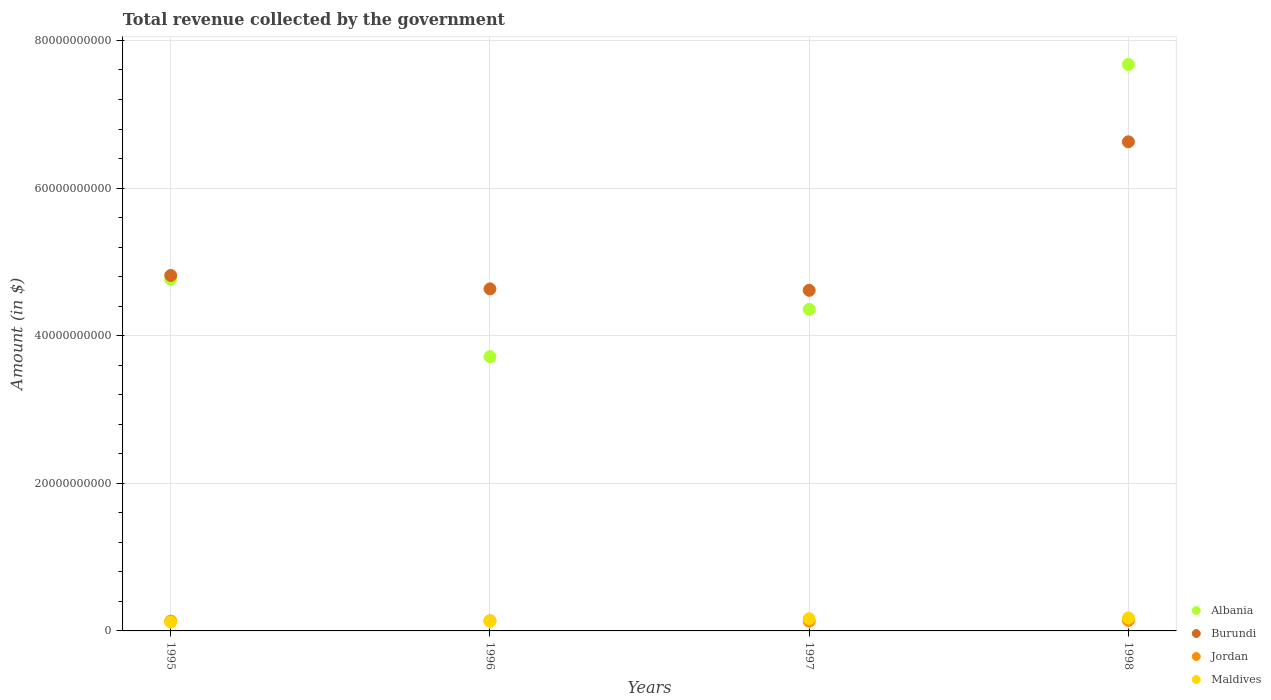What is the total revenue collected by the government in Albania in 1995?
Keep it short and to the point. 4.76e+1. Across all years, what is the maximum total revenue collected by the government in Albania?
Your response must be concise. 7.67e+1. Across all years, what is the minimum total revenue collected by the government in Jordan?
Your answer should be very brief. 1.31e+09. In which year was the total revenue collected by the government in Maldives maximum?
Keep it short and to the point. 1998. In which year was the total revenue collected by the government in Burundi minimum?
Your response must be concise. 1997. What is the total total revenue collected by the government in Maldives in the graph?
Give a very brief answer. 5.94e+09. What is the difference between the total revenue collected by the government in Maldives in 1995 and that in 1998?
Your answer should be very brief. -5.58e+08. What is the difference between the total revenue collected by the government in Maldives in 1997 and the total revenue collected by the government in Albania in 1995?
Ensure brevity in your answer.  -4.60e+1. What is the average total revenue collected by the government in Burundi per year?
Provide a succinct answer. 5.17e+1. In the year 1997, what is the difference between the total revenue collected by the government in Burundi and total revenue collected by the government in Jordan?
Your answer should be compact. 4.48e+1. In how many years, is the total revenue collected by the government in Jordan greater than 24000000000 $?
Provide a succinct answer. 0. What is the ratio of the total revenue collected by the government in Jordan in 1995 to that in 1998?
Keep it short and to the point. 0.94. Is the difference between the total revenue collected by the government in Burundi in 1995 and 1997 greater than the difference between the total revenue collected by the government in Jordan in 1995 and 1997?
Make the answer very short. Yes. What is the difference between the highest and the second highest total revenue collected by the government in Maldives?
Your response must be concise. 1.12e+08. What is the difference between the highest and the lowest total revenue collected by the government in Albania?
Offer a very short reply. 3.96e+1. In how many years, is the total revenue collected by the government in Jordan greater than the average total revenue collected by the government in Jordan taken over all years?
Ensure brevity in your answer.  2. Is it the case that in every year, the sum of the total revenue collected by the government in Burundi and total revenue collected by the government in Jordan  is greater than the sum of total revenue collected by the government in Albania and total revenue collected by the government in Maldives?
Provide a short and direct response. Yes. Is it the case that in every year, the sum of the total revenue collected by the government in Jordan and total revenue collected by the government in Maldives  is greater than the total revenue collected by the government in Burundi?
Your answer should be compact. No. Does the total revenue collected by the government in Maldives monotonically increase over the years?
Keep it short and to the point. Yes. Is the total revenue collected by the government in Jordan strictly less than the total revenue collected by the government in Burundi over the years?
Give a very brief answer. Yes. How many years are there in the graph?
Ensure brevity in your answer.  4. What is the difference between two consecutive major ticks on the Y-axis?
Provide a short and direct response. 2.00e+1. Are the values on the major ticks of Y-axis written in scientific E-notation?
Make the answer very short. No. Does the graph contain any zero values?
Your response must be concise. No. Does the graph contain grids?
Give a very brief answer. Yes. Where does the legend appear in the graph?
Offer a very short reply. Bottom right. How many legend labels are there?
Ensure brevity in your answer.  4. What is the title of the graph?
Your response must be concise. Total revenue collected by the government. What is the label or title of the X-axis?
Provide a short and direct response. Years. What is the label or title of the Y-axis?
Your answer should be very brief. Amount (in $). What is the Amount (in $) in Albania in 1995?
Give a very brief answer. 4.76e+1. What is the Amount (in $) of Burundi in 1995?
Offer a very short reply. 4.82e+1. What is the Amount (in $) of Jordan in 1995?
Make the answer very short. 1.33e+09. What is the Amount (in $) in Maldives in 1995?
Your answer should be compact. 1.21e+09. What is the Amount (in $) in Albania in 1996?
Your response must be concise. 3.72e+1. What is the Amount (in $) in Burundi in 1996?
Your answer should be compact. 4.63e+1. What is the Amount (in $) in Jordan in 1996?
Give a very brief answer. 1.36e+09. What is the Amount (in $) in Maldives in 1996?
Your answer should be very brief. 1.32e+09. What is the Amount (in $) in Albania in 1997?
Ensure brevity in your answer.  4.36e+1. What is the Amount (in $) of Burundi in 1997?
Your response must be concise. 4.61e+1. What is the Amount (in $) in Jordan in 1997?
Your answer should be compact. 1.31e+09. What is the Amount (in $) in Maldives in 1997?
Ensure brevity in your answer.  1.65e+09. What is the Amount (in $) in Albania in 1998?
Make the answer very short. 7.67e+1. What is the Amount (in $) of Burundi in 1998?
Give a very brief answer. 6.63e+1. What is the Amount (in $) in Jordan in 1998?
Keep it short and to the point. 1.42e+09. What is the Amount (in $) of Maldives in 1998?
Your answer should be very brief. 1.76e+09. Across all years, what is the maximum Amount (in $) in Albania?
Offer a very short reply. 7.67e+1. Across all years, what is the maximum Amount (in $) in Burundi?
Keep it short and to the point. 6.63e+1. Across all years, what is the maximum Amount (in $) in Jordan?
Your answer should be very brief. 1.42e+09. Across all years, what is the maximum Amount (in $) in Maldives?
Offer a very short reply. 1.76e+09. Across all years, what is the minimum Amount (in $) in Albania?
Keep it short and to the point. 3.72e+1. Across all years, what is the minimum Amount (in $) of Burundi?
Keep it short and to the point. 4.61e+1. Across all years, what is the minimum Amount (in $) in Jordan?
Give a very brief answer. 1.31e+09. Across all years, what is the minimum Amount (in $) of Maldives?
Your response must be concise. 1.21e+09. What is the total Amount (in $) of Albania in the graph?
Your response must be concise. 2.05e+11. What is the total Amount (in $) in Burundi in the graph?
Ensure brevity in your answer.  2.07e+11. What is the total Amount (in $) in Jordan in the graph?
Your answer should be compact. 5.43e+09. What is the total Amount (in $) of Maldives in the graph?
Offer a terse response. 5.94e+09. What is the difference between the Amount (in $) in Albania in 1995 and that in 1996?
Keep it short and to the point. 1.05e+1. What is the difference between the Amount (in $) in Burundi in 1995 and that in 1996?
Make the answer very short. 1.81e+09. What is the difference between the Amount (in $) in Jordan in 1995 and that in 1996?
Offer a very short reply. -3.30e+07. What is the difference between the Amount (in $) in Maldives in 1995 and that in 1996?
Provide a succinct answer. -1.16e+08. What is the difference between the Amount (in $) of Albania in 1995 and that in 1997?
Provide a succinct answer. 4.08e+09. What is the difference between the Amount (in $) in Burundi in 1995 and that in 1997?
Offer a very short reply. 2.01e+09. What is the difference between the Amount (in $) of Jordan in 1995 and that in 1997?
Your answer should be compact. 1.93e+07. What is the difference between the Amount (in $) of Maldives in 1995 and that in 1997?
Offer a very short reply. -4.46e+08. What is the difference between the Amount (in $) of Albania in 1995 and that in 1998?
Keep it short and to the point. -2.91e+1. What is the difference between the Amount (in $) in Burundi in 1995 and that in 1998?
Give a very brief answer. -1.81e+1. What is the difference between the Amount (in $) in Jordan in 1995 and that in 1998?
Give a very brief answer. -9.02e+07. What is the difference between the Amount (in $) in Maldives in 1995 and that in 1998?
Make the answer very short. -5.58e+08. What is the difference between the Amount (in $) in Albania in 1996 and that in 1997?
Provide a short and direct response. -6.41e+09. What is the difference between the Amount (in $) in Jordan in 1996 and that in 1997?
Provide a succinct answer. 5.23e+07. What is the difference between the Amount (in $) in Maldives in 1996 and that in 1997?
Offer a very short reply. -3.30e+08. What is the difference between the Amount (in $) of Albania in 1996 and that in 1998?
Make the answer very short. -3.96e+1. What is the difference between the Amount (in $) of Burundi in 1996 and that in 1998?
Your response must be concise. -1.99e+1. What is the difference between the Amount (in $) in Jordan in 1996 and that in 1998?
Offer a very short reply. -5.73e+07. What is the difference between the Amount (in $) of Maldives in 1996 and that in 1998?
Keep it short and to the point. -4.42e+08. What is the difference between the Amount (in $) of Albania in 1997 and that in 1998?
Offer a terse response. -3.32e+1. What is the difference between the Amount (in $) in Burundi in 1997 and that in 1998?
Your answer should be very brief. -2.01e+1. What is the difference between the Amount (in $) of Jordan in 1997 and that in 1998?
Give a very brief answer. -1.10e+08. What is the difference between the Amount (in $) of Maldives in 1997 and that in 1998?
Make the answer very short. -1.12e+08. What is the difference between the Amount (in $) of Albania in 1995 and the Amount (in $) of Burundi in 1996?
Your response must be concise. 1.30e+09. What is the difference between the Amount (in $) of Albania in 1995 and the Amount (in $) of Jordan in 1996?
Provide a succinct answer. 4.63e+1. What is the difference between the Amount (in $) of Albania in 1995 and the Amount (in $) of Maldives in 1996?
Your answer should be very brief. 4.63e+1. What is the difference between the Amount (in $) in Burundi in 1995 and the Amount (in $) in Jordan in 1996?
Ensure brevity in your answer.  4.68e+1. What is the difference between the Amount (in $) of Burundi in 1995 and the Amount (in $) of Maldives in 1996?
Provide a succinct answer. 4.68e+1. What is the difference between the Amount (in $) of Jordan in 1995 and the Amount (in $) of Maldives in 1996?
Your answer should be compact. 9.48e+06. What is the difference between the Amount (in $) of Albania in 1995 and the Amount (in $) of Burundi in 1997?
Your answer should be compact. 1.50e+09. What is the difference between the Amount (in $) in Albania in 1995 and the Amount (in $) in Jordan in 1997?
Offer a very short reply. 4.63e+1. What is the difference between the Amount (in $) of Albania in 1995 and the Amount (in $) of Maldives in 1997?
Make the answer very short. 4.60e+1. What is the difference between the Amount (in $) in Burundi in 1995 and the Amount (in $) in Jordan in 1997?
Your response must be concise. 4.68e+1. What is the difference between the Amount (in $) of Burundi in 1995 and the Amount (in $) of Maldives in 1997?
Make the answer very short. 4.65e+1. What is the difference between the Amount (in $) in Jordan in 1995 and the Amount (in $) in Maldives in 1997?
Provide a short and direct response. -3.21e+08. What is the difference between the Amount (in $) of Albania in 1995 and the Amount (in $) of Burundi in 1998?
Provide a succinct answer. -1.86e+1. What is the difference between the Amount (in $) in Albania in 1995 and the Amount (in $) in Jordan in 1998?
Your answer should be compact. 4.62e+1. What is the difference between the Amount (in $) of Albania in 1995 and the Amount (in $) of Maldives in 1998?
Keep it short and to the point. 4.59e+1. What is the difference between the Amount (in $) of Burundi in 1995 and the Amount (in $) of Jordan in 1998?
Provide a short and direct response. 4.67e+1. What is the difference between the Amount (in $) in Burundi in 1995 and the Amount (in $) in Maldives in 1998?
Offer a very short reply. 4.64e+1. What is the difference between the Amount (in $) of Jordan in 1995 and the Amount (in $) of Maldives in 1998?
Ensure brevity in your answer.  -4.33e+08. What is the difference between the Amount (in $) of Albania in 1996 and the Amount (in $) of Burundi in 1997?
Provide a succinct answer. -8.99e+09. What is the difference between the Amount (in $) in Albania in 1996 and the Amount (in $) in Jordan in 1997?
Ensure brevity in your answer.  3.58e+1. What is the difference between the Amount (in $) of Albania in 1996 and the Amount (in $) of Maldives in 1997?
Provide a succinct answer. 3.55e+1. What is the difference between the Amount (in $) in Burundi in 1996 and the Amount (in $) in Jordan in 1997?
Your answer should be compact. 4.50e+1. What is the difference between the Amount (in $) of Burundi in 1996 and the Amount (in $) of Maldives in 1997?
Give a very brief answer. 4.47e+1. What is the difference between the Amount (in $) of Jordan in 1996 and the Amount (in $) of Maldives in 1997?
Make the answer very short. -2.88e+08. What is the difference between the Amount (in $) in Albania in 1996 and the Amount (in $) in Burundi in 1998?
Ensure brevity in your answer.  -2.91e+1. What is the difference between the Amount (in $) of Albania in 1996 and the Amount (in $) of Jordan in 1998?
Your response must be concise. 3.57e+1. What is the difference between the Amount (in $) of Albania in 1996 and the Amount (in $) of Maldives in 1998?
Your response must be concise. 3.54e+1. What is the difference between the Amount (in $) in Burundi in 1996 and the Amount (in $) in Jordan in 1998?
Make the answer very short. 4.49e+1. What is the difference between the Amount (in $) of Burundi in 1996 and the Amount (in $) of Maldives in 1998?
Make the answer very short. 4.46e+1. What is the difference between the Amount (in $) of Jordan in 1996 and the Amount (in $) of Maldives in 1998?
Provide a succinct answer. -4.00e+08. What is the difference between the Amount (in $) in Albania in 1997 and the Amount (in $) in Burundi in 1998?
Give a very brief answer. -2.27e+1. What is the difference between the Amount (in $) in Albania in 1997 and the Amount (in $) in Jordan in 1998?
Make the answer very short. 4.21e+1. What is the difference between the Amount (in $) of Albania in 1997 and the Amount (in $) of Maldives in 1998?
Offer a terse response. 4.18e+1. What is the difference between the Amount (in $) in Burundi in 1997 and the Amount (in $) in Jordan in 1998?
Give a very brief answer. 4.47e+1. What is the difference between the Amount (in $) of Burundi in 1997 and the Amount (in $) of Maldives in 1998?
Your response must be concise. 4.44e+1. What is the difference between the Amount (in $) in Jordan in 1997 and the Amount (in $) in Maldives in 1998?
Make the answer very short. -4.52e+08. What is the average Amount (in $) of Albania per year?
Your answer should be very brief. 5.13e+1. What is the average Amount (in $) of Burundi per year?
Provide a succinct answer. 5.17e+1. What is the average Amount (in $) in Jordan per year?
Offer a very short reply. 1.36e+09. What is the average Amount (in $) in Maldives per year?
Make the answer very short. 1.49e+09. In the year 1995, what is the difference between the Amount (in $) of Albania and Amount (in $) of Burundi?
Give a very brief answer. -5.09e+08. In the year 1995, what is the difference between the Amount (in $) in Albania and Amount (in $) in Jordan?
Provide a short and direct response. 4.63e+1. In the year 1995, what is the difference between the Amount (in $) of Albania and Amount (in $) of Maldives?
Your answer should be compact. 4.64e+1. In the year 1995, what is the difference between the Amount (in $) of Burundi and Amount (in $) of Jordan?
Provide a short and direct response. 4.68e+1. In the year 1995, what is the difference between the Amount (in $) of Burundi and Amount (in $) of Maldives?
Your answer should be compact. 4.70e+1. In the year 1995, what is the difference between the Amount (in $) of Jordan and Amount (in $) of Maldives?
Provide a short and direct response. 1.25e+08. In the year 1996, what is the difference between the Amount (in $) of Albania and Amount (in $) of Burundi?
Provide a short and direct response. -9.19e+09. In the year 1996, what is the difference between the Amount (in $) in Albania and Amount (in $) in Jordan?
Your answer should be compact. 3.58e+1. In the year 1996, what is the difference between the Amount (in $) in Albania and Amount (in $) in Maldives?
Ensure brevity in your answer.  3.58e+1. In the year 1996, what is the difference between the Amount (in $) of Burundi and Amount (in $) of Jordan?
Make the answer very short. 4.50e+1. In the year 1996, what is the difference between the Amount (in $) of Burundi and Amount (in $) of Maldives?
Offer a very short reply. 4.50e+1. In the year 1996, what is the difference between the Amount (in $) in Jordan and Amount (in $) in Maldives?
Provide a short and direct response. 4.24e+07. In the year 1997, what is the difference between the Amount (in $) of Albania and Amount (in $) of Burundi?
Offer a terse response. -2.57e+09. In the year 1997, what is the difference between the Amount (in $) of Albania and Amount (in $) of Jordan?
Your response must be concise. 4.23e+1. In the year 1997, what is the difference between the Amount (in $) in Albania and Amount (in $) in Maldives?
Your answer should be very brief. 4.19e+1. In the year 1997, what is the difference between the Amount (in $) of Burundi and Amount (in $) of Jordan?
Your answer should be compact. 4.48e+1. In the year 1997, what is the difference between the Amount (in $) in Burundi and Amount (in $) in Maldives?
Provide a short and direct response. 4.45e+1. In the year 1997, what is the difference between the Amount (in $) of Jordan and Amount (in $) of Maldives?
Your response must be concise. -3.40e+08. In the year 1998, what is the difference between the Amount (in $) of Albania and Amount (in $) of Burundi?
Ensure brevity in your answer.  1.05e+1. In the year 1998, what is the difference between the Amount (in $) of Albania and Amount (in $) of Jordan?
Keep it short and to the point. 7.53e+1. In the year 1998, what is the difference between the Amount (in $) in Albania and Amount (in $) in Maldives?
Offer a terse response. 7.50e+1. In the year 1998, what is the difference between the Amount (in $) of Burundi and Amount (in $) of Jordan?
Make the answer very short. 6.48e+1. In the year 1998, what is the difference between the Amount (in $) of Burundi and Amount (in $) of Maldives?
Provide a succinct answer. 6.45e+1. In the year 1998, what is the difference between the Amount (in $) of Jordan and Amount (in $) of Maldives?
Ensure brevity in your answer.  -3.42e+08. What is the ratio of the Amount (in $) in Albania in 1995 to that in 1996?
Make the answer very short. 1.28. What is the ratio of the Amount (in $) of Burundi in 1995 to that in 1996?
Provide a succinct answer. 1.04. What is the ratio of the Amount (in $) in Jordan in 1995 to that in 1996?
Provide a succinct answer. 0.98. What is the ratio of the Amount (in $) in Maldives in 1995 to that in 1996?
Ensure brevity in your answer.  0.91. What is the ratio of the Amount (in $) in Albania in 1995 to that in 1997?
Keep it short and to the point. 1.09. What is the ratio of the Amount (in $) of Burundi in 1995 to that in 1997?
Your answer should be compact. 1.04. What is the ratio of the Amount (in $) in Jordan in 1995 to that in 1997?
Keep it short and to the point. 1.01. What is the ratio of the Amount (in $) of Maldives in 1995 to that in 1997?
Make the answer very short. 0.73. What is the ratio of the Amount (in $) in Albania in 1995 to that in 1998?
Offer a terse response. 0.62. What is the ratio of the Amount (in $) in Burundi in 1995 to that in 1998?
Give a very brief answer. 0.73. What is the ratio of the Amount (in $) in Jordan in 1995 to that in 1998?
Your answer should be compact. 0.94. What is the ratio of the Amount (in $) of Maldives in 1995 to that in 1998?
Your answer should be very brief. 0.68. What is the ratio of the Amount (in $) in Albania in 1996 to that in 1997?
Offer a very short reply. 0.85. What is the ratio of the Amount (in $) in Jordan in 1996 to that in 1997?
Give a very brief answer. 1.04. What is the ratio of the Amount (in $) in Albania in 1996 to that in 1998?
Ensure brevity in your answer.  0.48. What is the ratio of the Amount (in $) in Burundi in 1996 to that in 1998?
Give a very brief answer. 0.7. What is the ratio of the Amount (in $) in Jordan in 1996 to that in 1998?
Your response must be concise. 0.96. What is the ratio of the Amount (in $) of Maldives in 1996 to that in 1998?
Give a very brief answer. 0.75. What is the ratio of the Amount (in $) in Albania in 1997 to that in 1998?
Make the answer very short. 0.57. What is the ratio of the Amount (in $) of Burundi in 1997 to that in 1998?
Your response must be concise. 0.7. What is the ratio of the Amount (in $) of Jordan in 1997 to that in 1998?
Provide a succinct answer. 0.92. What is the ratio of the Amount (in $) in Maldives in 1997 to that in 1998?
Provide a short and direct response. 0.94. What is the difference between the highest and the second highest Amount (in $) of Albania?
Your answer should be very brief. 2.91e+1. What is the difference between the highest and the second highest Amount (in $) of Burundi?
Offer a terse response. 1.81e+1. What is the difference between the highest and the second highest Amount (in $) in Jordan?
Your response must be concise. 5.73e+07. What is the difference between the highest and the second highest Amount (in $) in Maldives?
Your response must be concise. 1.12e+08. What is the difference between the highest and the lowest Amount (in $) of Albania?
Provide a succinct answer. 3.96e+1. What is the difference between the highest and the lowest Amount (in $) in Burundi?
Ensure brevity in your answer.  2.01e+1. What is the difference between the highest and the lowest Amount (in $) of Jordan?
Provide a short and direct response. 1.10e+08. What is the difference between the highest and the lowest Amount (in $) of Maldives?
Offer a very short reply. 5.58e+08. 